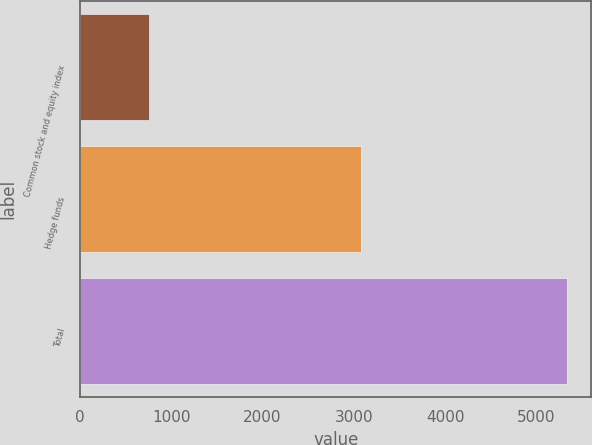Convert chart to OTSL. <chart><loc_0><loc_0><loc_500><loc_500><bar_chart><fcel>Common stock and equity index<fcel>Hedge funds<fcel>Total<nl><fcel>756<fcel>3075<fcel>5336<nl></chart> 